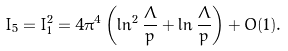Convert formula to latex. <formula><loc_0><loc_0><loc_500><loc_500>I _ { 5 } = I _ { 1 } ^ { 2 } = 4 \pi ^ { 4 } \left ( \ln ^ { 2 } \frac { \Lambda } { p } + \ln \frac { \Lambda } { p } \right ) + O ( 1 ) .</formula> 